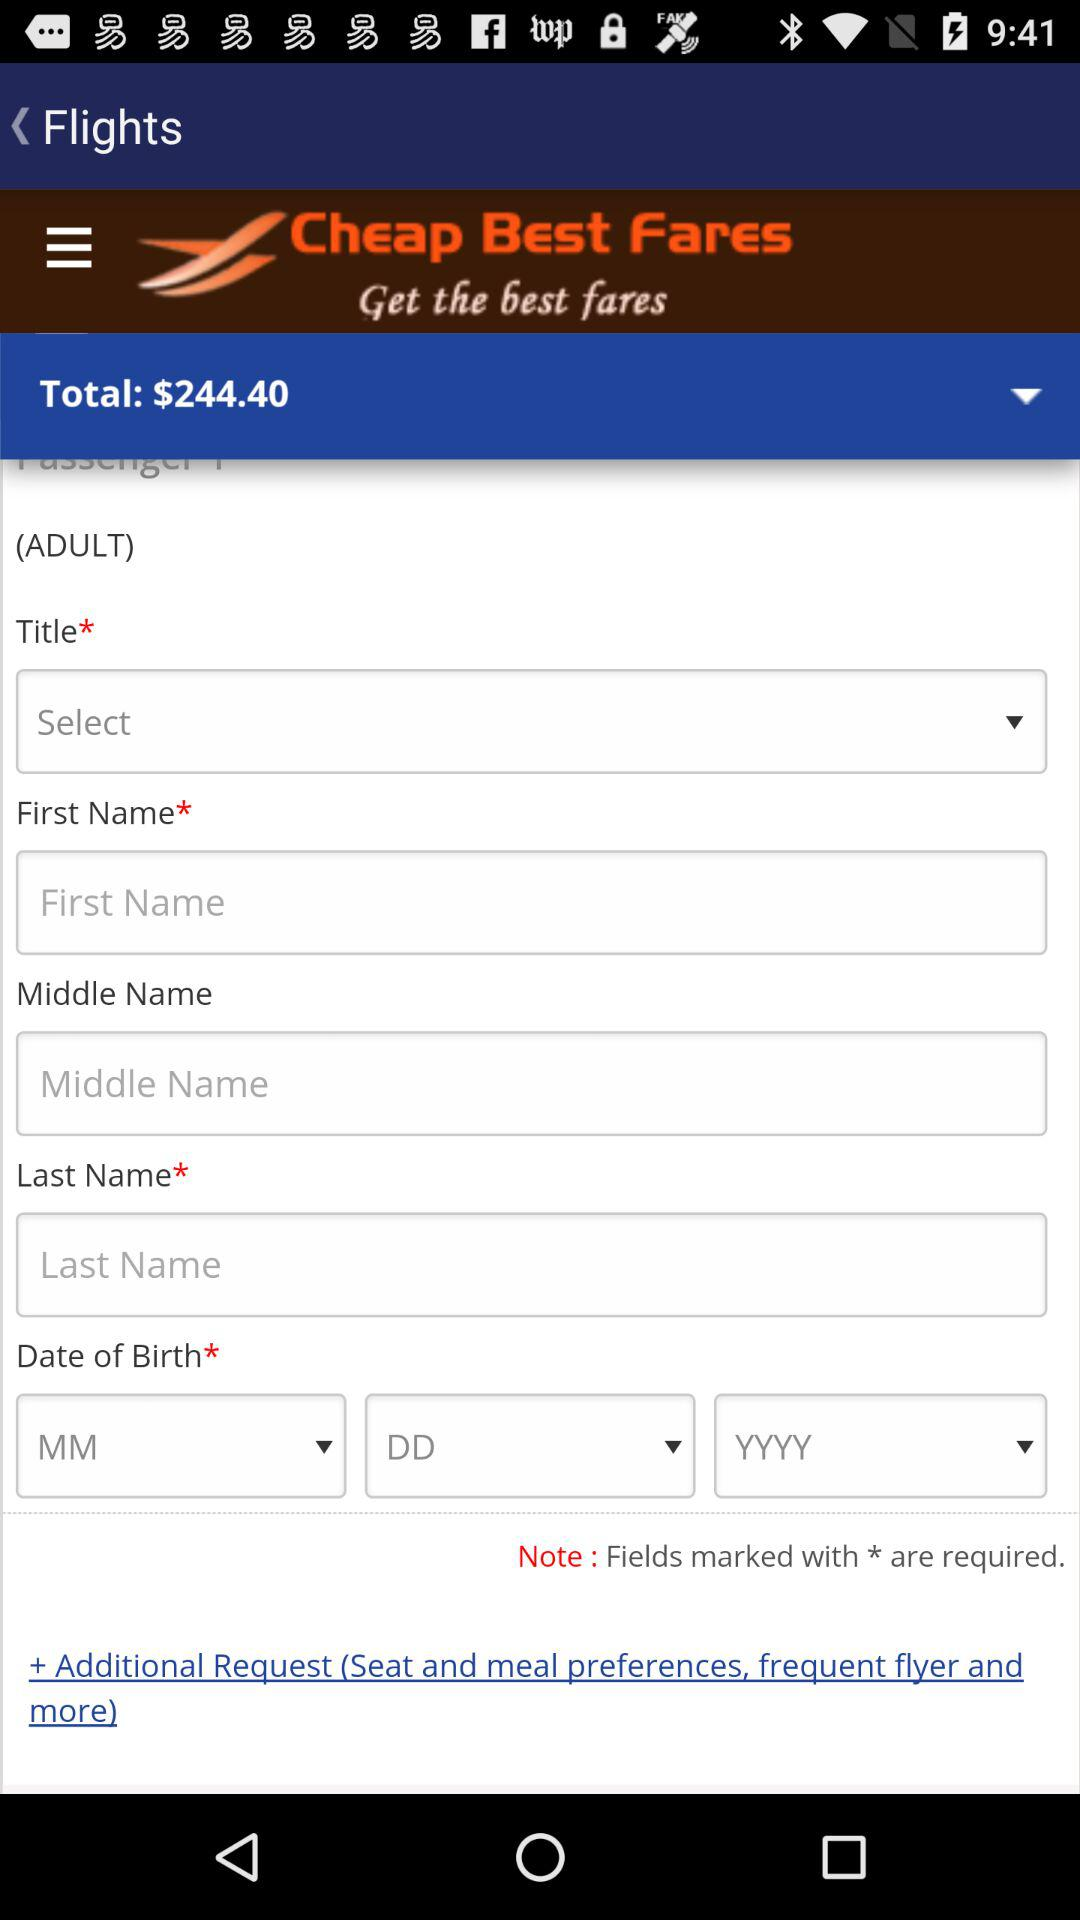How many text inputs are there for the passenger's name?
Answer the question using a single word or phrase. 3 